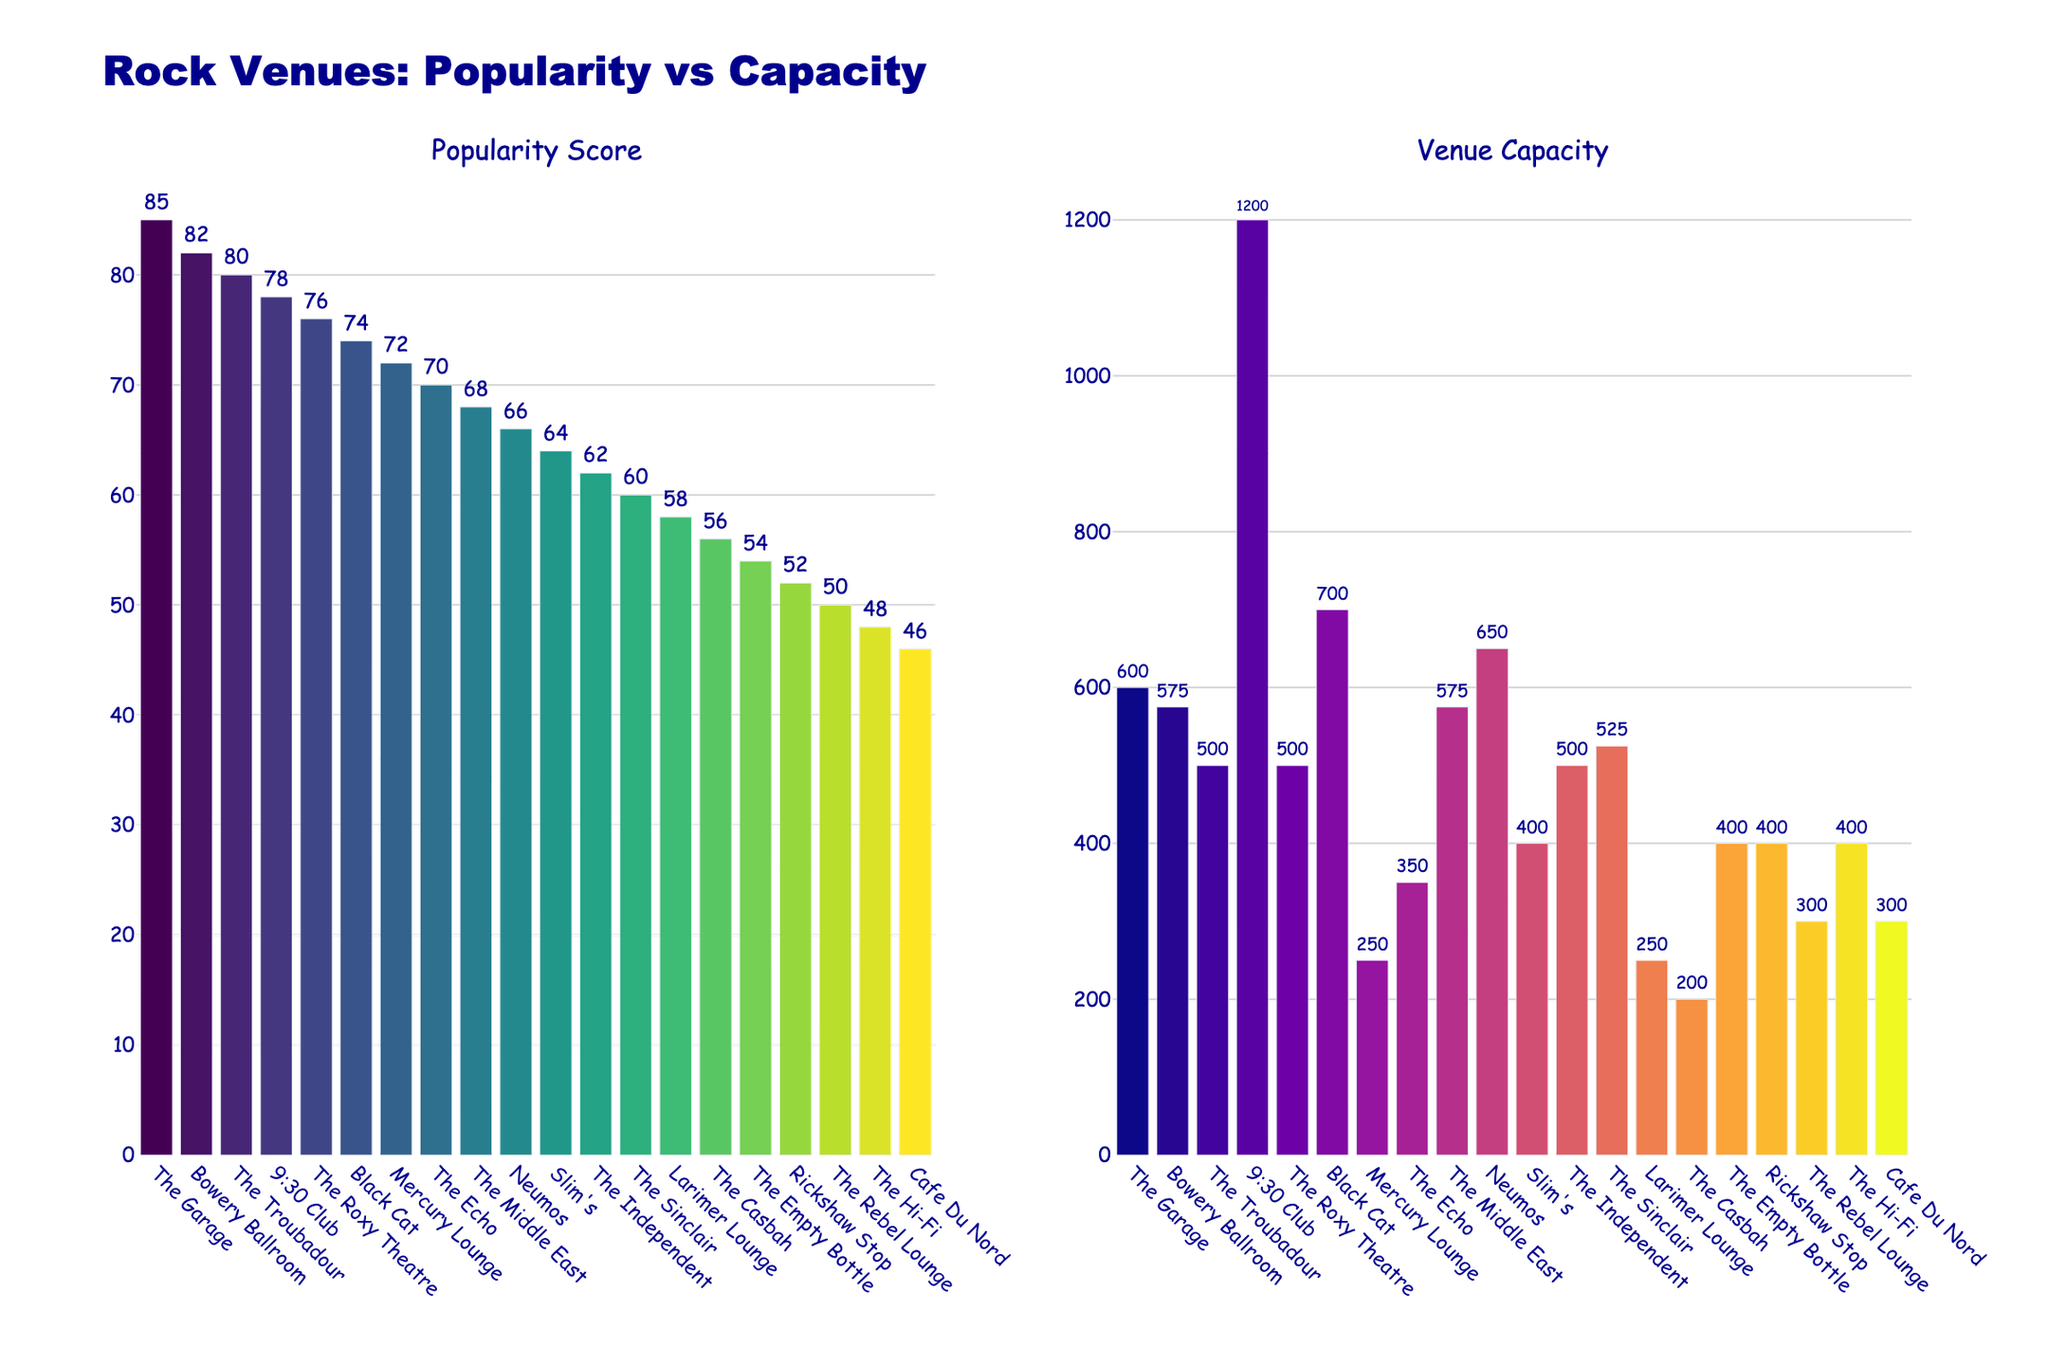What is the most popular venue for upcoming rock bands? Look at the bar chart on the left, "Popularity Score" subfigure. The venue with the highest bar is the most popular.
Answer: The Garage Which venue has the largest capacity? Look at the bar chart on the right, "Venue Capacity" subfigure. The venue with the tallest bar has the largest capacity.
Answer: 9:30 Club Which venue with a capacity of 500 seats has the highest popularity score? Identify the bars corresponding to venues with a capacity of 500 on the "Venue Capacity" subfigure. Then, check the "Popularity Score" subfigure to find out which among them has the highest bar.
Answer: The Troubadour Is there any venue with a popularity score lower than 60 but a capacity higher than 350? Check the "Popularity Score" subfigure for bars lower than 60, find their corresponding venues, then verify their capacity on the "Venue Capacity" subfigure.
Answer: Yes, Rickshaw Stop and The Hi-Fi Which venue has the smallest capacity but isn't the least popular? In the "Venue Capacity" subfigure, identify the smallest capacity (200). Check the corresponding popularity score on the left and verify it's not the smallest.
Answer: The Casbah What is the average capacity of the top three most popular venues? Identify the top three venues with the highest popularity scores: The Garage (600), Bowery Ballroom (575), The Troubadour (500). Calculate their average: (600 + 575 + 500) / 3 = 558.33.
Answer: 558.33 Compare the popularity score of Neumos and The Sinclair. Which one is higher and by how much? Find the bars for Neumos and The Sinclair on the popularity chart. Subtract their scores: 66 - 60.
Answer: Neumos, by 6 How many venues have a capacity between 400 and 600 and a popularity score above 70? Count the bars in the capacity subfigure between 400-600 and cross-check with the popularity subfigure for those above 70.
Answer: Four: The Garage, Bowery Ballroom, The Troubadour, Black Cat Is there any venue with the same capacity but different popularity scores? Look for bars in the "Venue Capacity" subfigure that have the same height but then check their popularity scores in the other subfigure.
Answer: Yes, Rickshaw Stop, The Hi-Fi, and The Empty Bottle all have a capacity of 400 but different scores 